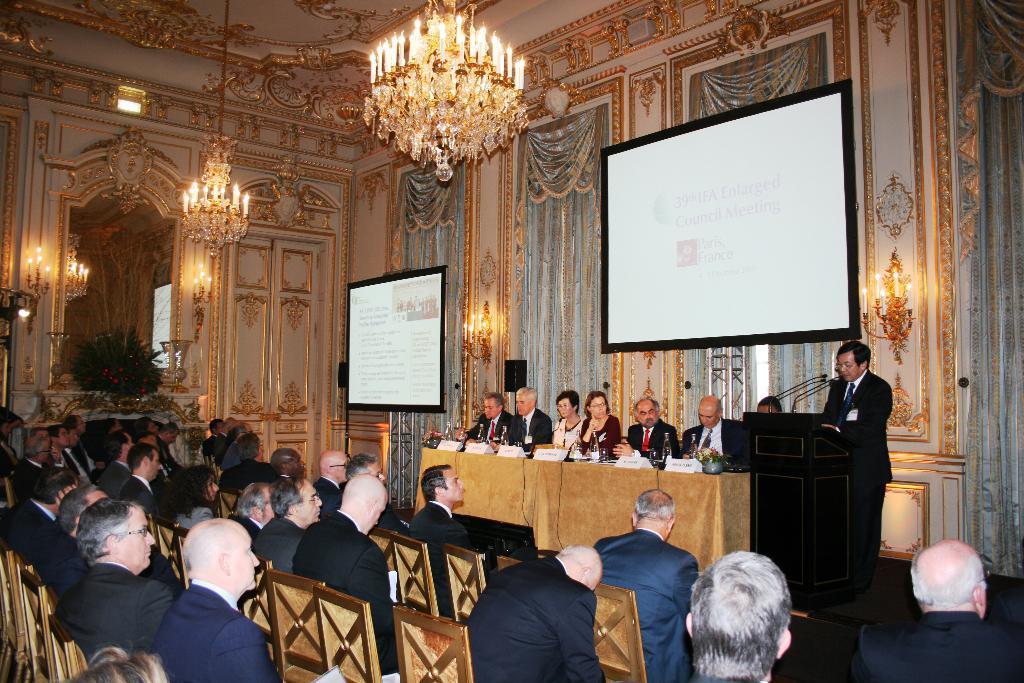Could you give a brief overview of what you see in this image? people are listening to a man whose speaking at a podium and there are few other people on the stage. 